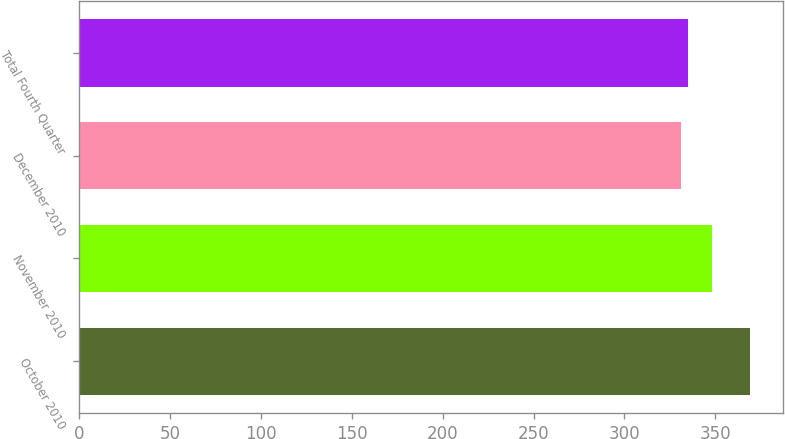Convert chart to OTSL. <chart><loc_0><loc_0><loc_500><loc_500><bar_chart><fcel>October 2010<fcel>November 2010<fcel>December 2010<fcel>Total Fourth Quarter<nl><fcel>369.1<fcel>348.3<fcel>331.1<fcel>334.9<nl></chart> 